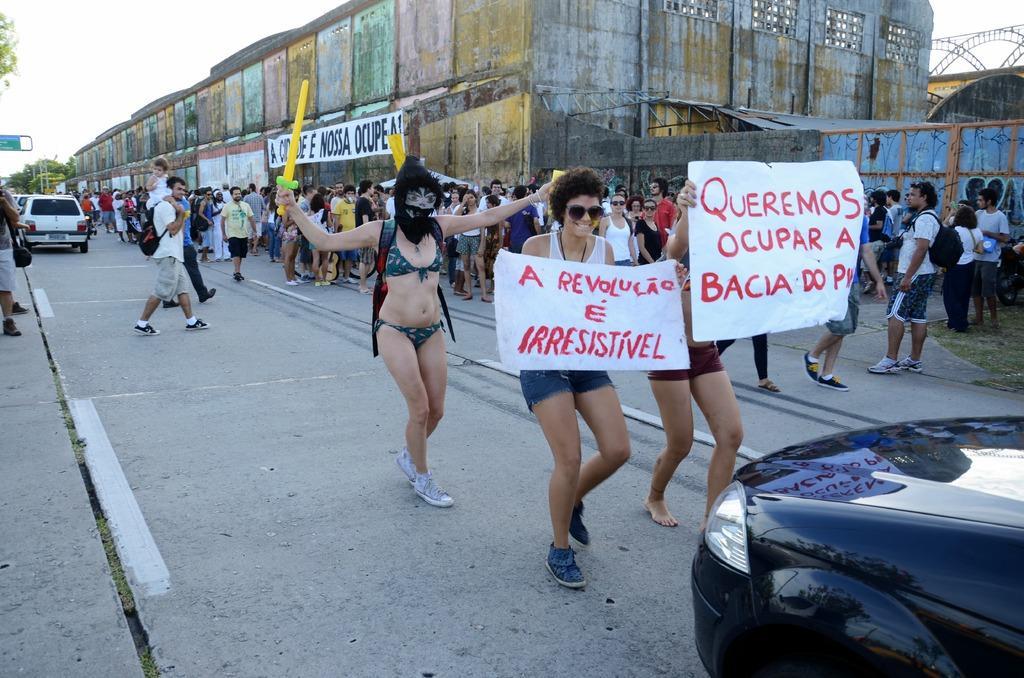Please provide a concise description of this image. In the foreground of this image, there is a car on the right bottom corner. In the background, there are persons standing and holding banners on the road. There is also a woman walking and holding a toy sword and we can also see building, trees, vehicles in the background. 